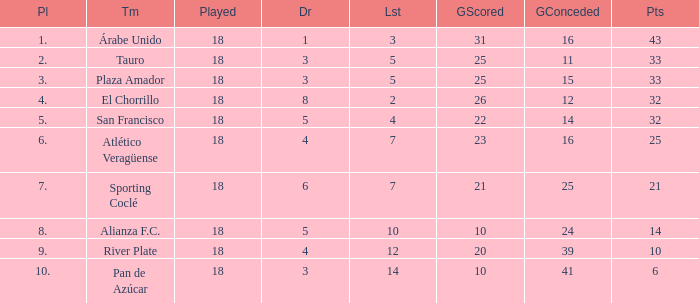How many goals were conceded by teams with 32 points, more than 2 losses and more than 22 goals scored? 0.0. 